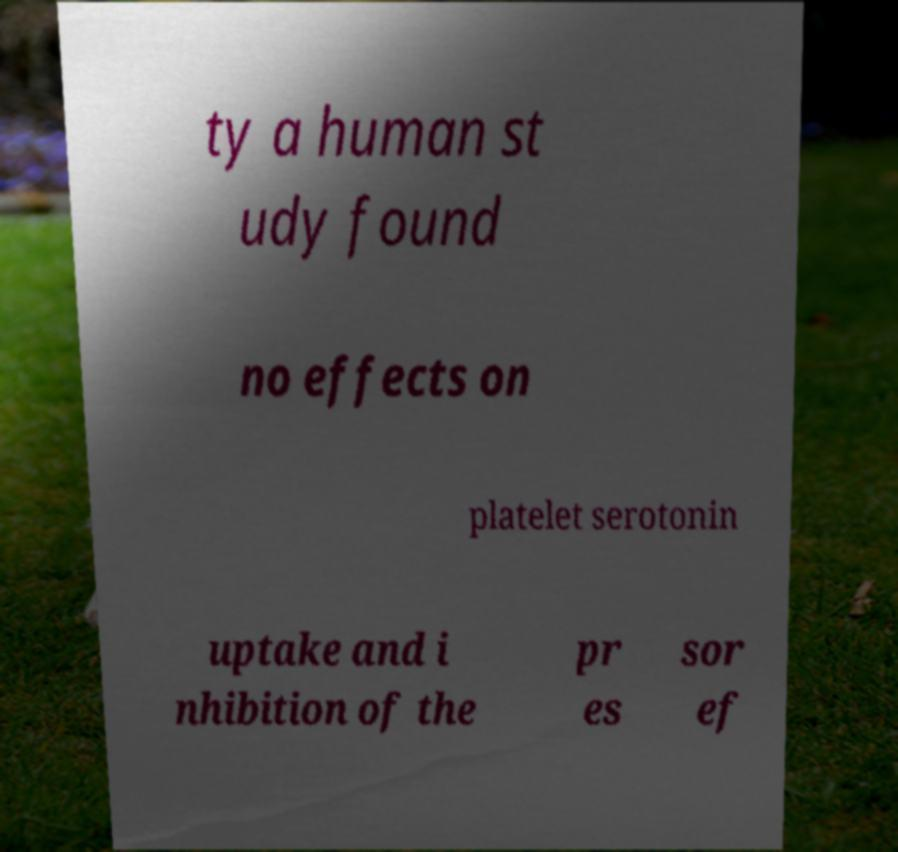I need the written content from this picture converted into text. Can you do that? ty a human st udy found no effects on platelet serotonin uptake and i nhibition of the pr es sor ef 